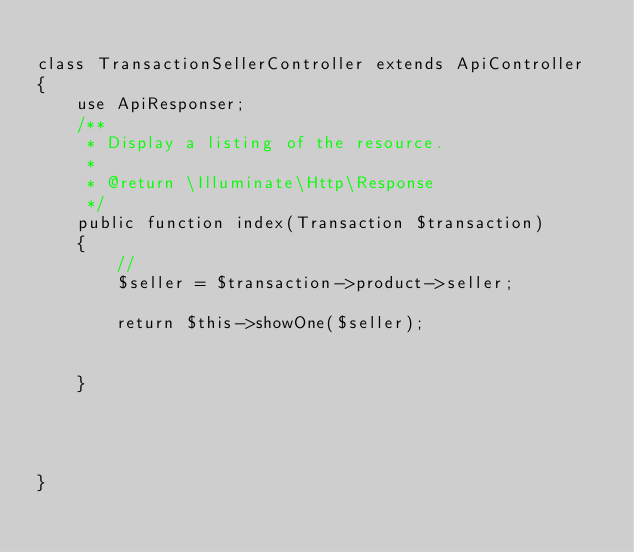Convert code to text. <code><loc_0><loc_0><loc_500><loc_500><_PHP_>
class TransactionSellerController extends ApiController
{
    use ApiResponser;
    /**
     * Display a listing of the resource.
     *
     * @return \Illuminate\Http\Response
     */
    public function index(Transaction $transaction)
    {
        //
        $seller = $transaction->product->seller;

        return $this->showOne($seller);


    }




}
</code> 